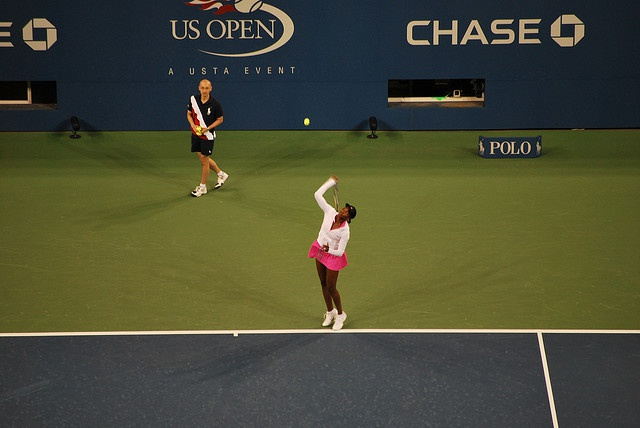Describe the objects in this image and their specific colors. I can see people in black, lightgray, maroon, and brown tones, people in black, brown, lightgray, and olive tones, tennis racket in black, olive, and gray tones, and sports ball in black, khaki, olive, darkgreen, and gray tones in this image. 